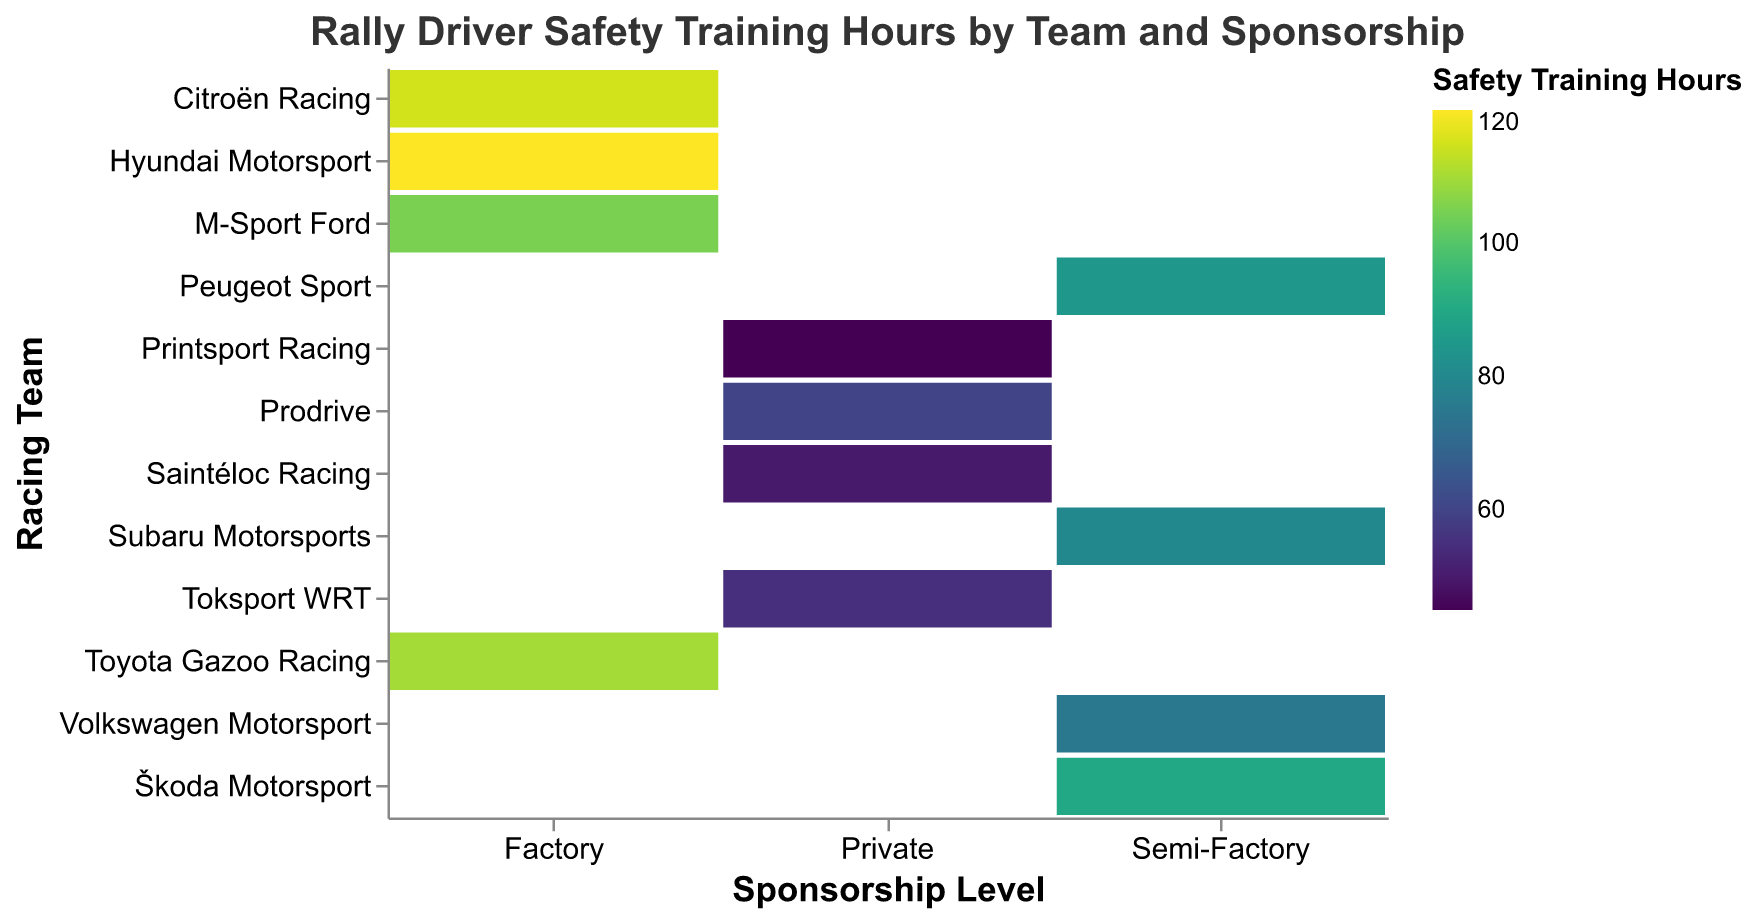Which team has the highest safety training hours in the Factory sponsorship category? By looking at the cells in the Factory column and identifying the highest value in that column, Hyundai Motorsport has the highest training hours with 120 hours.
Answer: Hyundai Motorsport What's the difference in safety training hours between Prodrive and Printsport Racing? Find the safety training hours for both teams: Prodrive has 60 hours, and Printsport Racing has 45 hours. Subtract the smaller value from the larger value: 60 - 45 = 15.
Answer: 15 Which sponsorship category has the lowest total safety training hours? Add the training hours for each sponsorship category: Factory (120 + 110 + 105 + 115 = 450), Semi-Factory (90 + 85 + 80 + 75 = 330), and Private (60 + 55 + 50 + 45 = 210). Private has the lowest total hours.
Answer: Private Is the average safety training hours for Factory teams higher than for Semi-Factory teams? Calculate the average for Factory (450/4 = 112.5) and for Semi-Factory (330/4 = 82.5). Compare the averages: 112.5 (Factory) is higher than 82.5 (Semi-Factory).
Answer: Yes What's the median value of the safety training hours for the Private sponsorship level? List the training hours for Private teams (45, 50, 55, 60) and find the middle value(s). The median, being the average of the two middle numbers (50 and 55), is (50+55)/2 = 52.5.
Answer: 52.5 Which team has the least safety training hours overall? Scan all the cells and identify the smallest value, which is 45 hours for Printsport Racing.
Answer: Printsport Racing How does the safety training hours distribution differ between Semi-Factory and Private categories? Compare the range and values: Semi-Factory ranges from 75 to 90 hours, while Private ranges from 45 to 60 hours. Semi-Factory has generally higher values than Private categories.
Answer: Semi-Factory has higher and tightly grouped hours compared to Private Does any team in the Private sponsorship category have more training hours than any team in the Semi-Factory category? Compare the maximum value in Private (Prodrive with 60) with the minimum value in Semi-Factory (Volkswagen Motorsport with 75). None of the Private teams exceed any Semi-Factory team.
Answer: No What is the total number of training hours devoted by Citroën Racing and Škoda Motorsport combined? Add the safety training hours of Citroën Racing (115) and Škoda Motorsport (90): 115 + 90 = 205.
Answer: 205 Which sponsorship level shows the least variation in training hours among its teams? Calculate the range (max - min) for each: Factory (120-105=15), Semi-Factory (90-75=15), Private (60-45=15). Variations are the same for all categories.
Answer: All have equal variation 